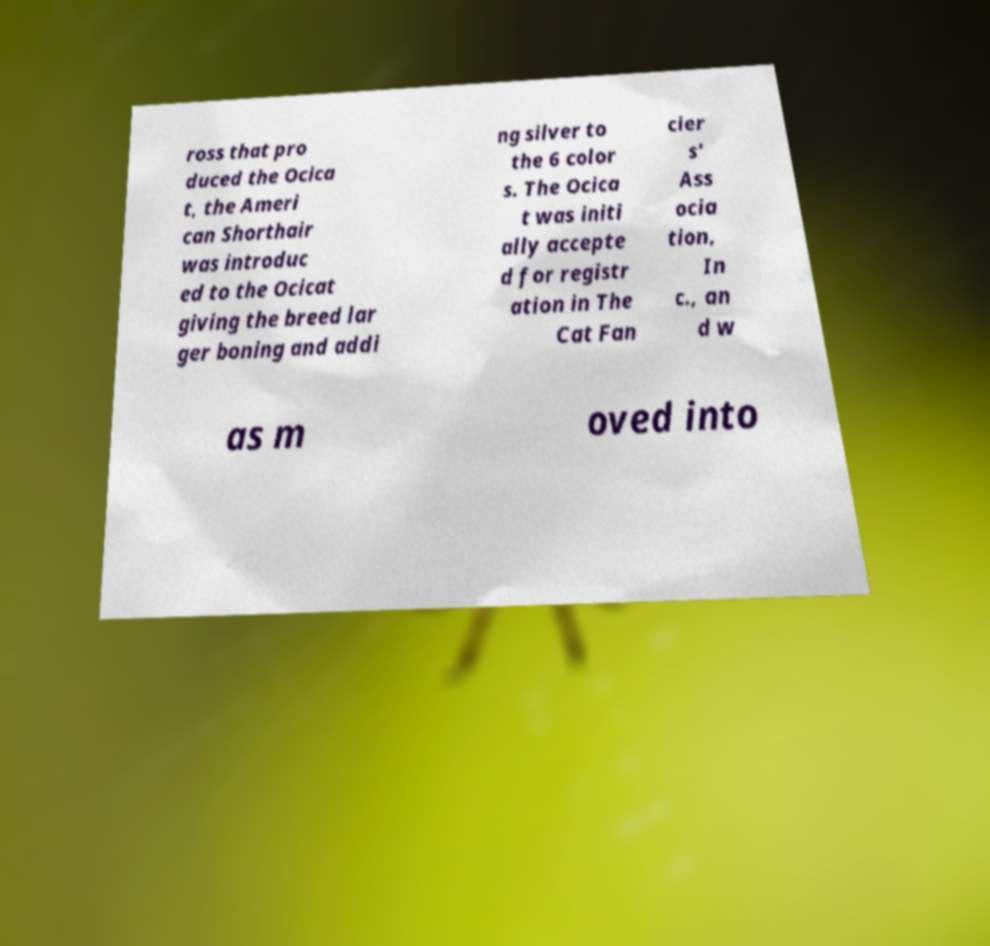For documentation purposes, I need the text within this image transcribed. Could you provide that? ross that pro duced the Ocica t, the Ameri can Shorthair was introduc ed to the Ocicat giving the breed lar ger boning and addi ng silver to the 6 color s. The Ocica t was initi ally accepte d for registr ation in The Cat Fan cier s' Ass ocia tion, In c., an d w as m oved into 